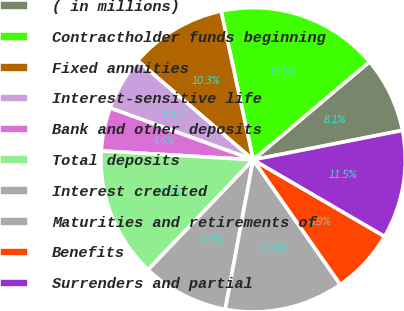<chart> <loc_0><loc_0><loc_500><loc_500><pie_chart><fcel>( in millions)<fcel>Contractholder funds beginning<fcel>Fixed annuities<fcel>Interest-sensitive life<fcel>Bank and other deposits<fcel>Total deposits<fcel>Interest credited<fcel>Maturities and retirements of<fcel>Benefits<fcel>Surrenders and partial<nl><fcel>8.05%<fcel>17.24%<fcel>10.34%<fcel>5.75%<fcel>4.6%<fcel>13.79%<fcel>9.2%<fcel>12.64%<fcel>6.9%<fcel>11.49%<nl></chart> 